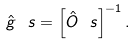<formula> <loc_0><loc_0><loc_500><loc_500>\hat { g } ^ { \ } s = \left [ \hat { O } ^ { \ } s \right ] ^ { - 1 } .</formula> 